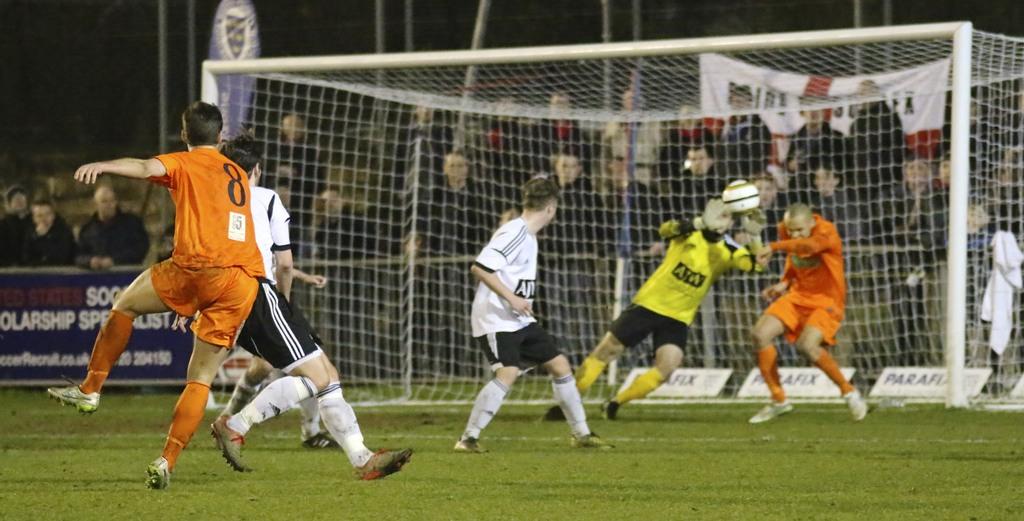What number does the player have on his back?
Keep it short and to the point. 8. 